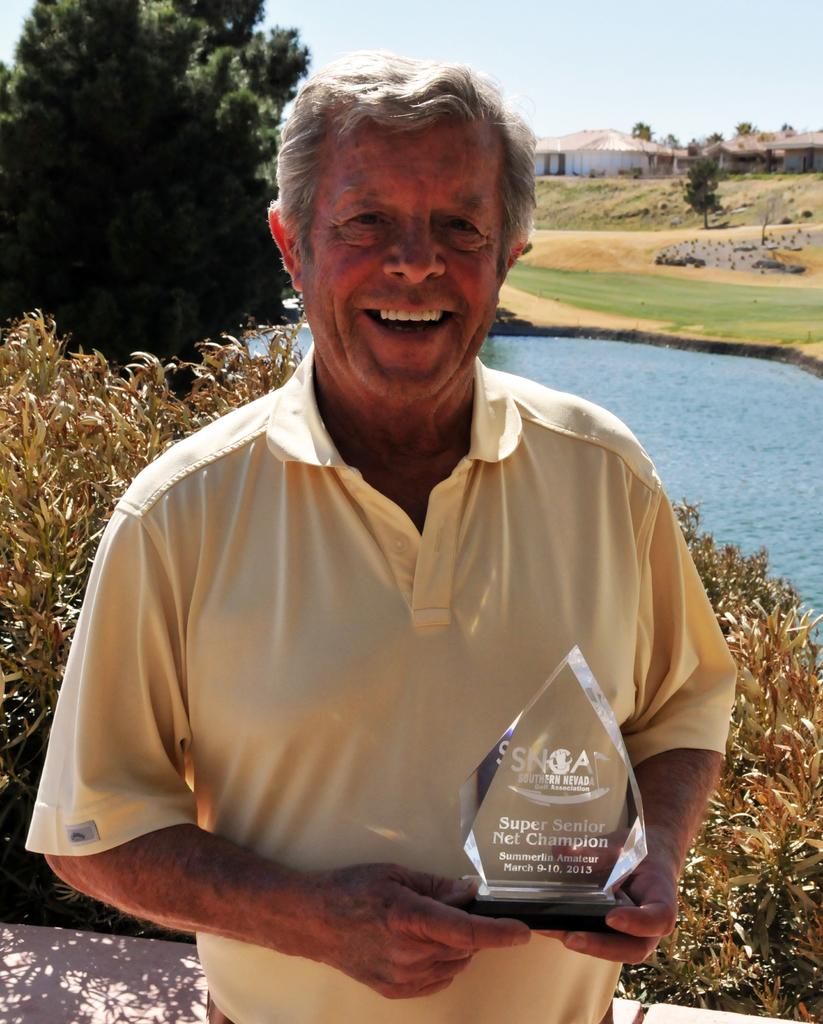What is the man in the image holding? The man is holding an award in the image. What is the man's expression in the image? The man is smiling in the image. What can be seen in the background of the image? There are trees, houses, a lake, and the sky visible in the background of the image. What type of page can be seen turning in the image? There is no page present in the image, so it cannot be determined if a page is turning. 